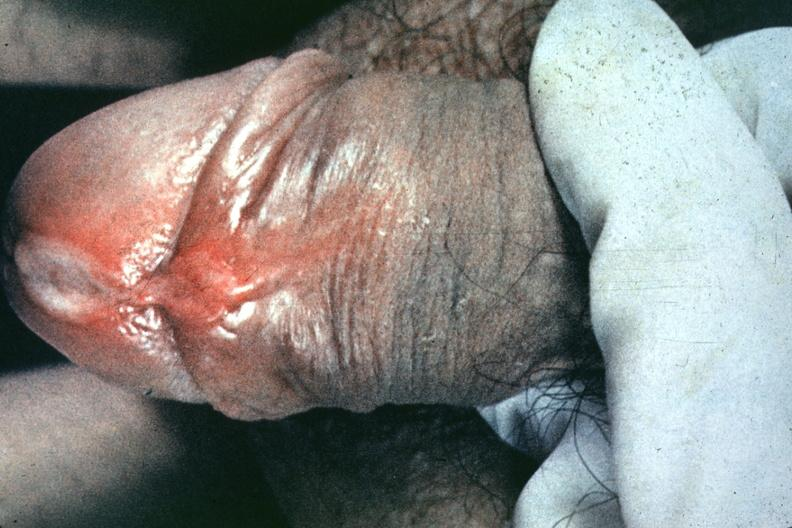s penis present?
Answer the question using a single word or phrase. Yes 